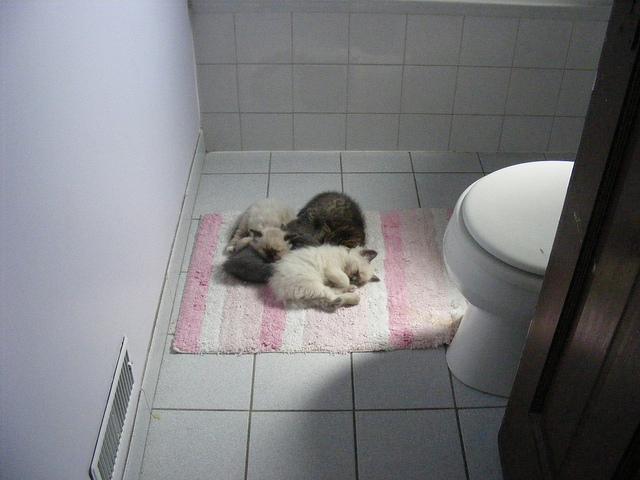How many kittens are there?
Give a very brief answer. 3. How many cats are there?
Give a very brief answer. 3. 